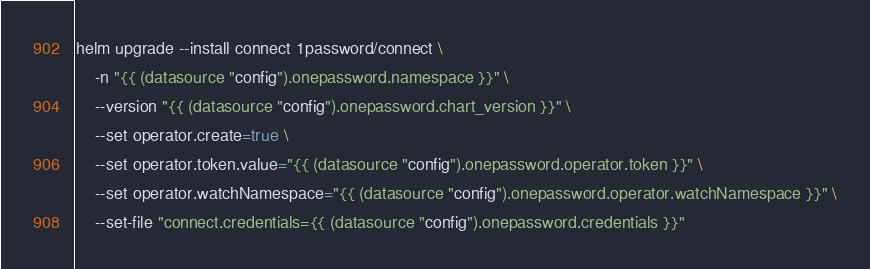<code> <loc_0><loc_0><loc_500><loc_500><_Bash_>helm upgrade --install connect 1password/connect \
    -n "{{ (datasource "config").onepassword.namespace }}" \
    --version "{{ (datasource "config").onepassword.chart_version }}" \
    --set operator.create=true \
    --set operator.token.value="{{ (datasource "config").onepassword.operator.token }}" \
    --set operator.watchNamespace="{{ (datasource "config").onepassword.operator.watchNamespace }}" \
    --set-file "connect.credentials={{ (datasource "config").onepassword.credentials }}"
</code> 